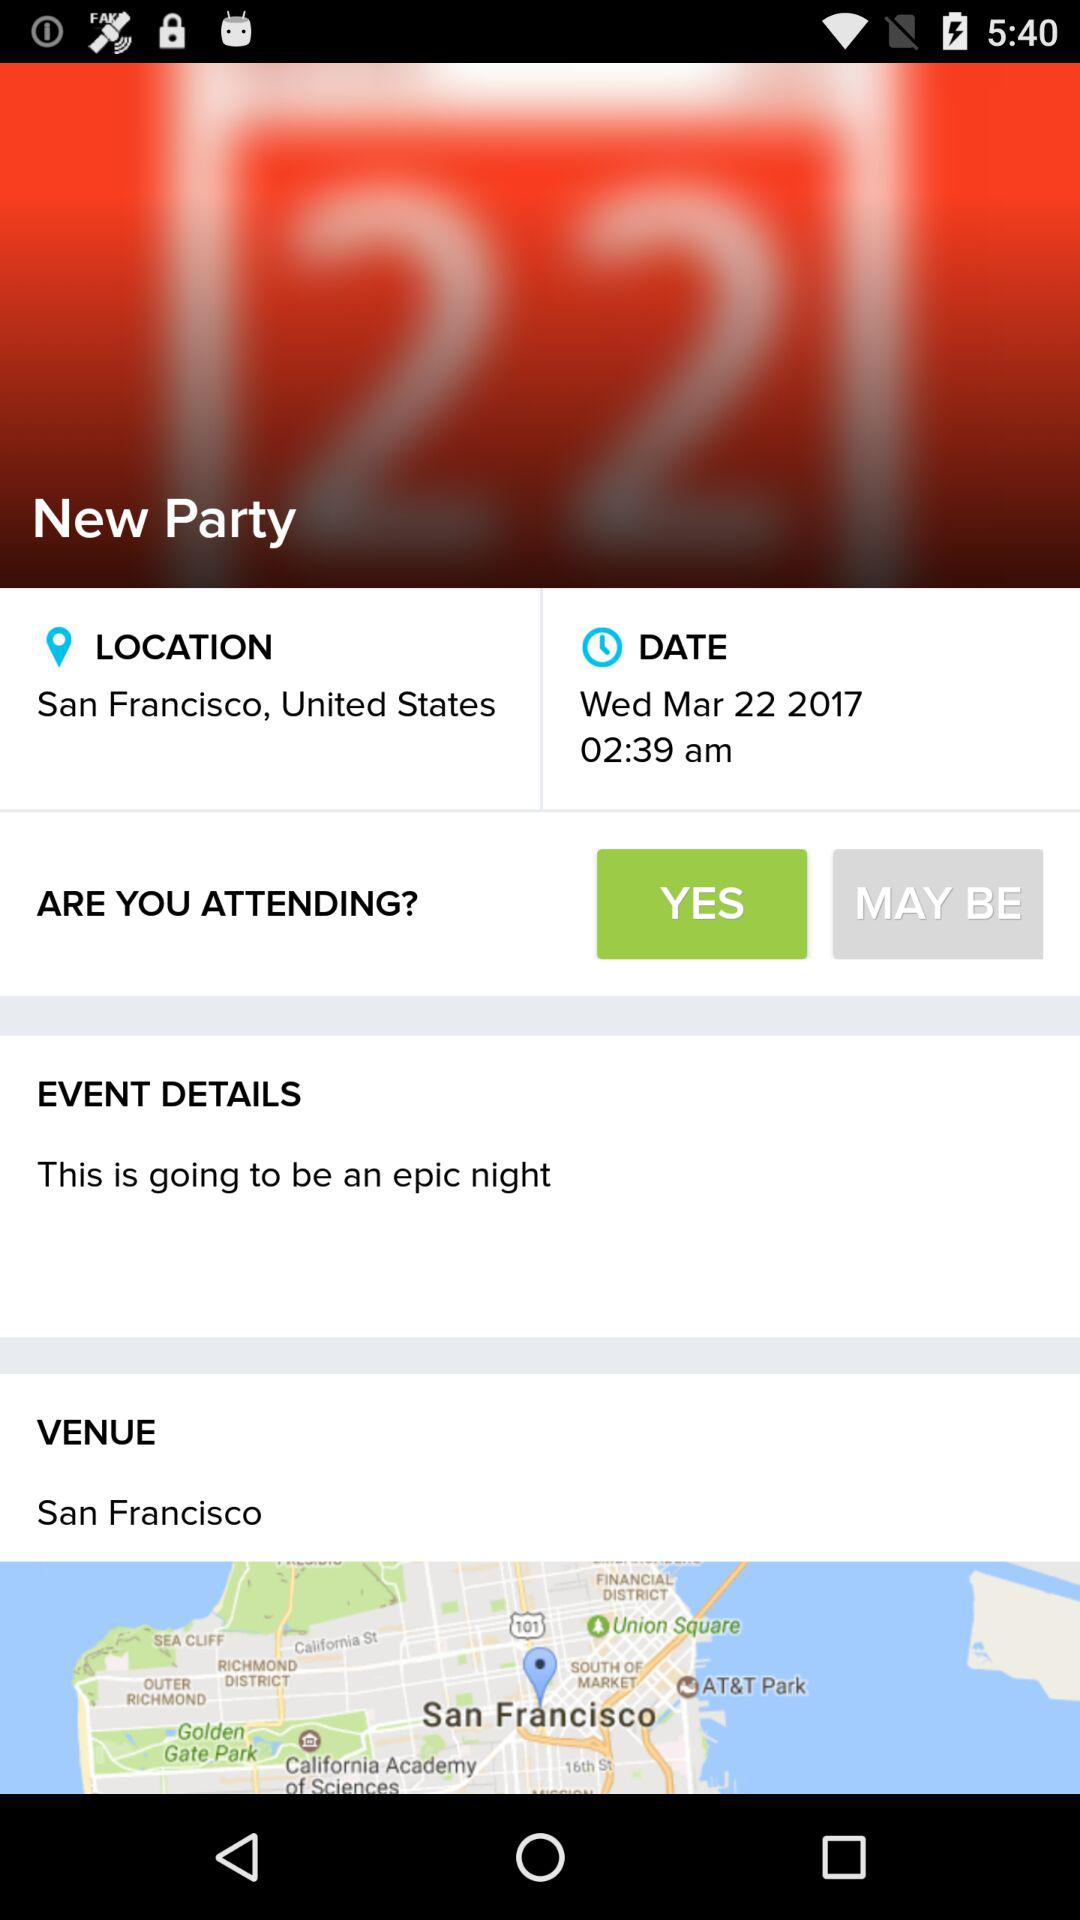What is the mentioned date? The mentioned date is Wednesday, March 22, 2017. 